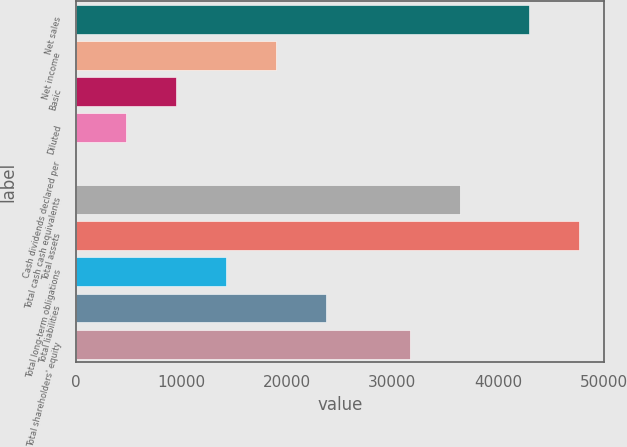<chart> <loc_0><loc_0><loc_500><loc_500><bar_chart><fcel>Net sales<fcel>Net income<fcel>Basic<fcel>Diluted<fcel>Cash dividends declared per<fcel>Total cash cash equivalents<fcel>Total assets<fcel>Total long-term obligations<fcel>Total liabilities<fcel>Total shareholders' equity<nl><fcel>42905<fcel>19001.9<fcel>9502.14<fcel>4752.28<fcel>2.42<fcel>36389.9<fcel>47654.9<fcel>14252<fcel>23751.7<fcel>31640<nl></chart> 